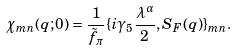<formula> <loc_0><loc_0><loc_500><loc_500>\chi _ { m n } ( q ; 0 ) = \frac { 1 } { \tilde { f } _ { \pi } } \{ i \gamma _ { 5 } \frac { \lambda ^ { \alpha } } { 2 } , S _ { F } ( q ) \} _ { m n } .</formula> 